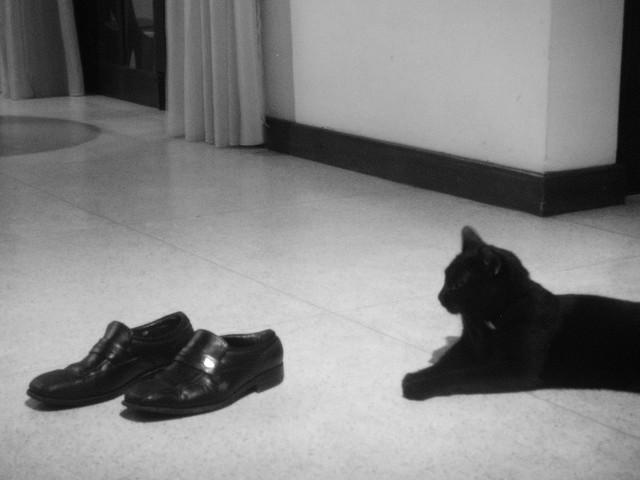How many airplane wheels are to be seen?
Give a very brief answer. 0. 